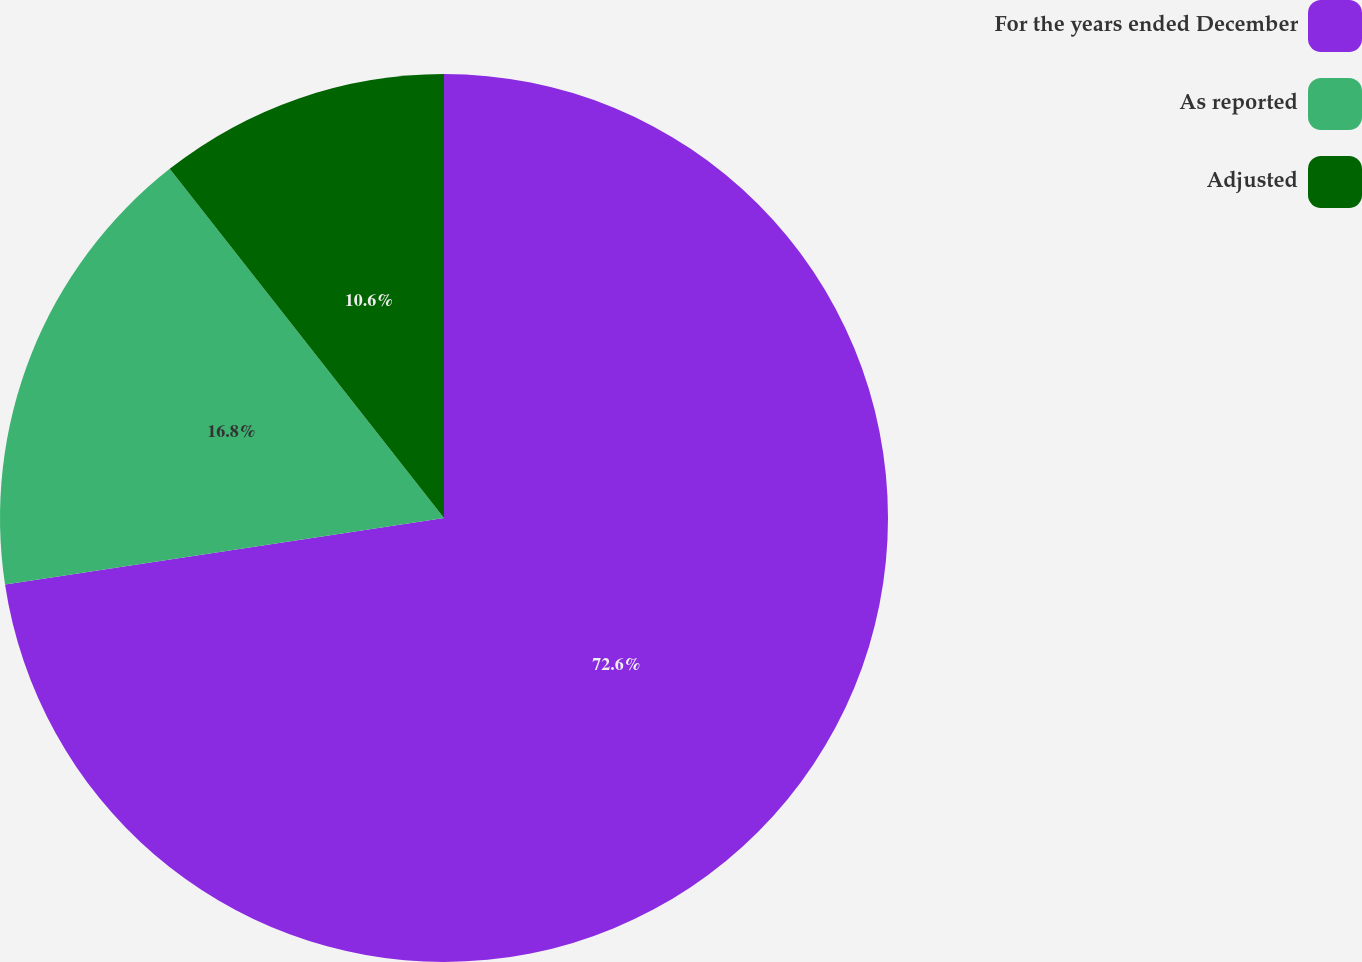<chart> <loc_0><loc_0><loc_500><loc_500><pie_chart><fcel>For the years ended December<fcel>As reported<fcel>Adjusted<nl><fcel>72.61%<fcel>16.8%<fcel>10.6%<nl></chart> 